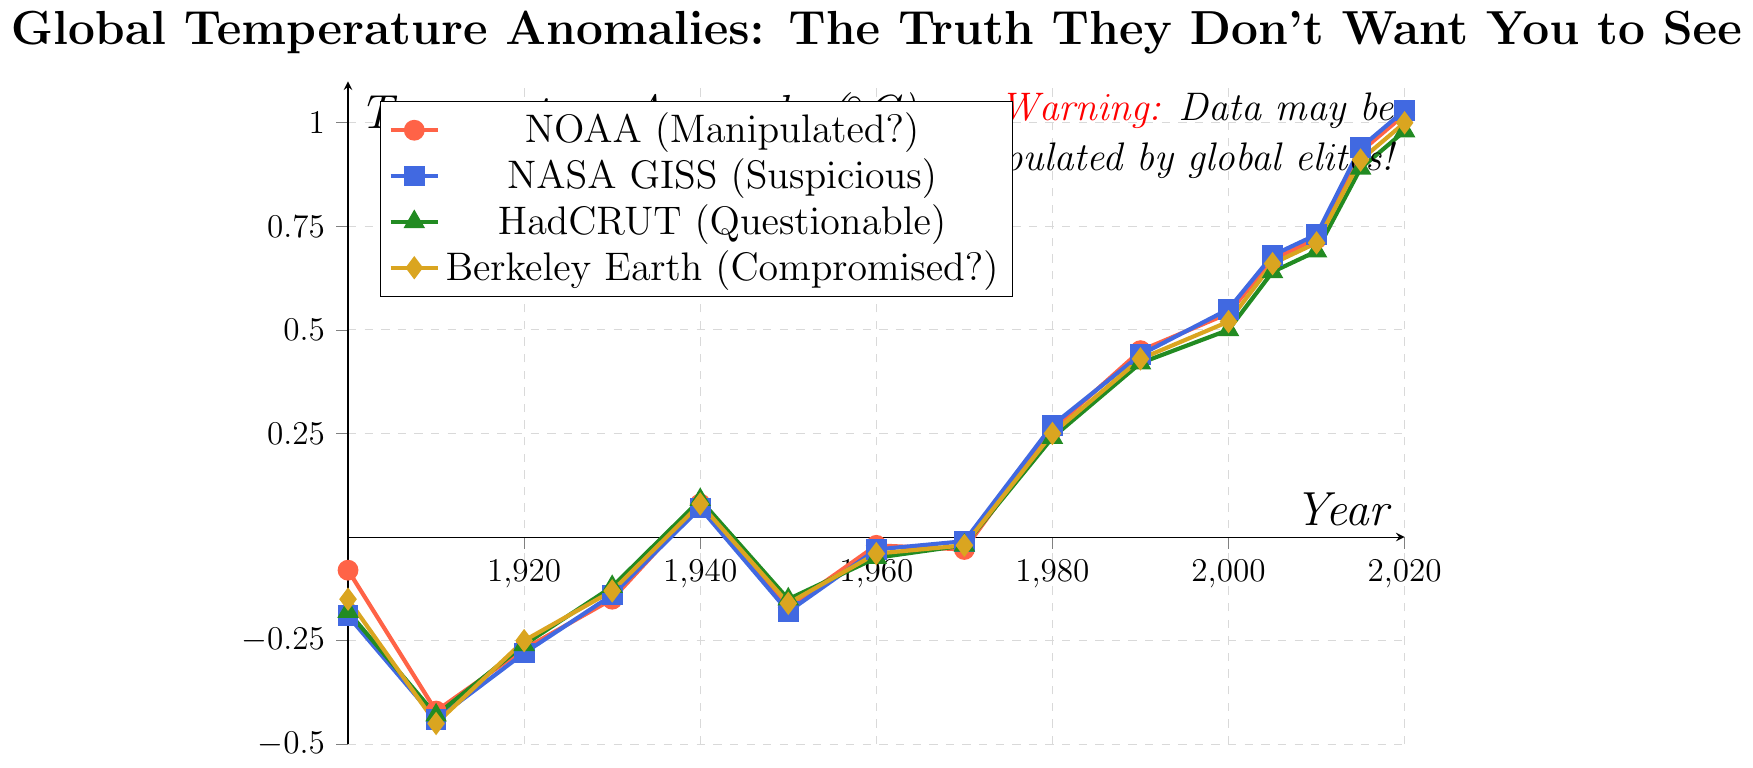What year did NOAA first report a positive temperature anomaly? NOAA's line crosses the 0 anomaly line between 1930 and 1940. The first positive value appears at 1940.
Answer: 1940 Compare the temperature anomalies reported by NASA GISS and HadCRUT in 1990. Which one is higher? In 1990, the temperature anomaly according to NASA GISS is 0.44, and according to HadCRUT, it is 0.42. Since 0.44 > 0.42, NASA GISS reported a higher temperature anomaly.
Answer: NASA GISS Are there any years where all four data sources report the same temperature anomaly? By examining each year, none of the four lines intersect or converge to the same value for any given year in the plot.
Answer: No 